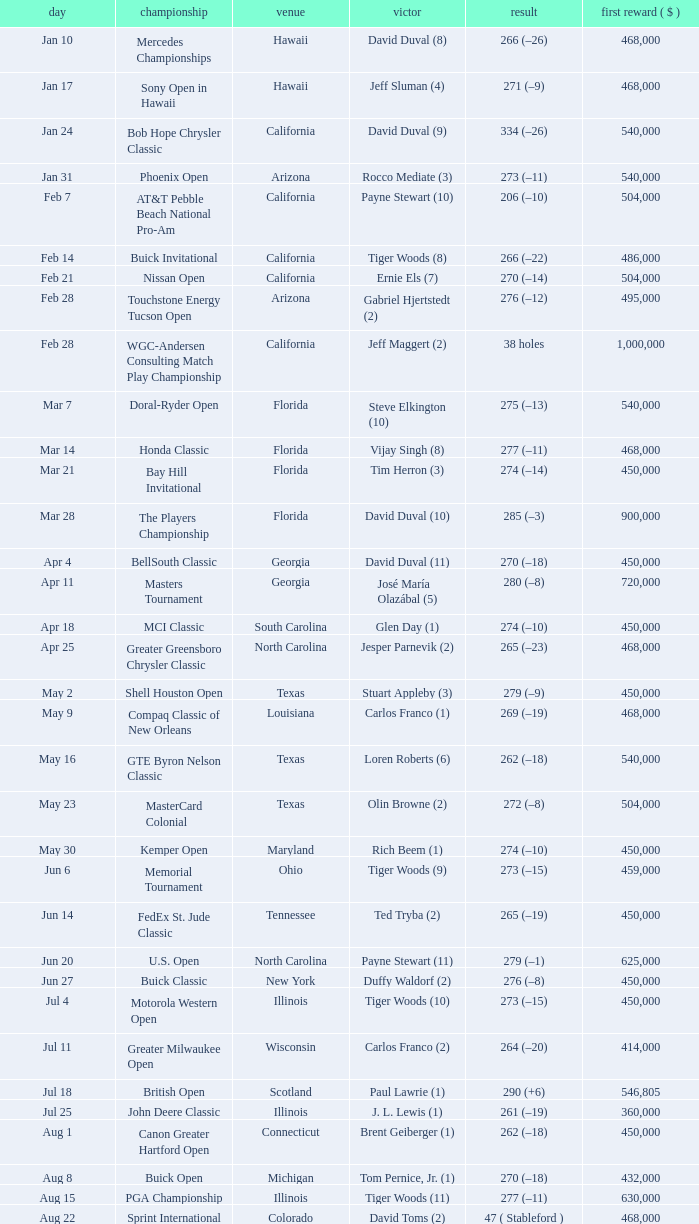What is the date of the Greater Greensboro Chrysler Classic? Apr 25. Parse the full table. {'header': ['day', 'championship', 'venue', 'victor', 'result', 'first reward ( $ )'], 'rows': [['Jan 10', 'Mercedes Championships', 'Hawaii', 'David Duval (8)', '266 (–26)', '468,000'], ['Jan 17', 'Sony Open in Hawaii', 'Hawaii', 'Jeff Sluman (4)', '271 (–9)', '468,000'], ['Jan 24', 'Bob Hope Chrysler Classic', 'California', 'David Duval (9)', '334 (–26)', '540,000'], ['Jan 31', 'Phoenix Open', 'Arizona', 'Rocco Mediate (3)', '273 (–11)', '540,000'], ['Feb 7', 'AT&T Pebble Beach National Pro-Am', 'California', 'Payne Stewart (10)', '206 (–10)', '504,000'], ['Feb 14', 'Buick Invitational', 'California', 'Tiger Woods (8)', '266 (–22)', '486,000'], ['Feb 21', 'Nissan Open', 'California', 'Ernie Els (7)', '270 (–14)', '504,000'], ['Feb 28', 'Touchstone Energy Tucson Open', 'Arizona', 'Gabriel Hjertstedt (2)', '276 (–12)', '495,000'], ['Feb 28', 'WGC-Andersen Consulting Match Play Championship', 'California', 'Jeff Maggert (2)', '38 holes', '1,000,000'], ['Mar 7', 'Doral-Ryder Open', 'Florida', 'Steve Elkington (10)', '275 (–13)', '540,000'], ['Mar 14', 'Honda Classic', 'Florida', 'Vijay Singh (8)', '277 (–11)', '468,000'], ['Mar 21', 'Bay Hill Invitational', 'Florida', 'Tim Herron (3)', '274 (–14)', '450,000'], ['Mar 28', 'The Players Championship', 'Florida', 'David Duval (10)', '285 (–3)', '900,000'], ['Apr 4', 'BellSouth Classic', 'Georgia', 'David Duval (11)', '270 (–18)', '450,000'], ['Apr 11', 'Masters Tournament', 'Georgia', 'José María Olazábal (5)', '280 (–8)', '720,000'], ['Apr 18', 'MCI Classic', 'South Carolina', 'Glen Day (1)', '274 (–10)', '450,000'], ['Apr 25', 'Greater Greensboro Chrysler Classic', 'North Carolina', 'Jesper Parnevik (2)', '265 (–23)', '468,000'], ['May 2', 'Shell Houston Open', 'Texas', 'Stuart Appleby (3)', '279 (–9)', '450,000'], ['May 9', 'Compaq Classic of New Orleans', 'Louisiana', 'Carlos Franco (1)', '269 (–19)', '468,000'], ['May 16', 'GTE Byron Nelson Classic', 'Texas', 'Loren Roberts (6)', '262 (–18)', '540,000'], ['May 23', 'MasterCard Colonial', 'Texas', 'Olin Browne (2)', '272 (–8)', '504,000'], ['May 30', 'Kemper Open', 'Maryland', 'Rich Beem (1)', '274 (–10)', '450,000'], ['Jun 6', 'Memorial Tournament', 'Ohio', 'Tiger Woods (9)', '273 (–15)', '459,000'], ['Jun 14', 'FedEx St. Jude Classic', 'Tennessee', 'Ted Tryba (2)', '265 (–19)', '450,000'], ['Jun 20', 'U.S. Open', 'North Carolina', 'Payne Stewart (11)', '279 (–1)', '625,000'], ['Jun 27', 'Buick Classic', 'New York', 'Duffy Waldorf (2)', '276 (–8)', '450,000'], ['Jul 4', 'Motorola Western Open', 'Illinois', 'Tiger Woods (10)', '273 (–15)', '450,000'], ['Jul 11', 'Greater Milwaukee Open', 'Wisconsin', 'Carlos Franco (2)', '264 (–20)', '414,000'], ['Jul 18', 'British Open', 'Scotland', 'Paul Lawrie (1)', '290 (+6)', '546,805'], ['Jul 25', 'John Deere Classic', 'Illinois', 'J. L. Lewis (1)', '261 (–19)', '360,000'], ['Aug 1', 'Canon Greater Hartford Open', 'Connecticut', 'Brent Geiberger (1)', '262 (–18)', '450,000'], ['Aug 8', 'Buick Open', 'Michigan', 'Tom Pernice, Jr. (1)', '270 (–18)', '432,000'], ['Aug 15', 'PGA Championship', 'Illinois', 'Tiger Woods (11)', '277 (–11)', '630,000'], ['Aug 22', 'Sprint International', 'Colorado', 'David Toms (2)', '47 ( Stableford )', '468,000'], ['Aug 29', 'Reno-Tahoe Open', 'Nevada', 'Notah Begay III (1)', '274 (–14)', '495,000'], ['Aug 29', 'WGC-NEC Invitational', 'Ohio', 'Tiger Woods (12)', '270 (–10)', '1,000,000'], ['Sep 5', 'Air Canada Championship', 'Canada', 'Mike Weir (1)', '266 (–18)', '450,000'], ['Sep 12', 'Bell Canadian Open', 'Canada', 'Hal Sutton (11)', '275 (–13)', '450,000'], ['Sep 19', 'B.C. Open', 'New York', 'Brad Faxon (5)', '273 (–15)', '288,000'], ['Sep 26', 'Westin Texas Open', 'Texas', 'Duffy Waldorf (3)', '270 (–18)', '360,000'], ['Oct 3', 'Buick Challenge', 'Georgia', 'David Toms (3)', '271 (–17)', '324,000'], ['Oct 10', 'Michelob Championship at Kingsmill', 'Virginia', 'Notah Begay III (2)', '274 (–10)', '450,000'], ['Oct 17', 'Las Vegas Invitational', 'Nevada', 'Jim Furyk (4)', '331 (–29)', '450,000'], ['Oct 24', 'National Car Rental Golf Classic Disney', 'Florida', 'Tiger Woods (13)', '271 (–17)', '450,000'], ['Oct 31', 'The Tour Championship', 'Texas', 'Tiger Woods (14)', '269 (–15)', '900,000'], ['Nov 1', 'Southern Farm Bureau Classic', 'Mississippi', 'Brian Henninger (2)', '202 (–14)', '360,000'], ['Nov 7', 'WGC-American Express Championship', 'Spain', 'Tiger Woods (15)', '278 (–6)', '1,000,000']]} 